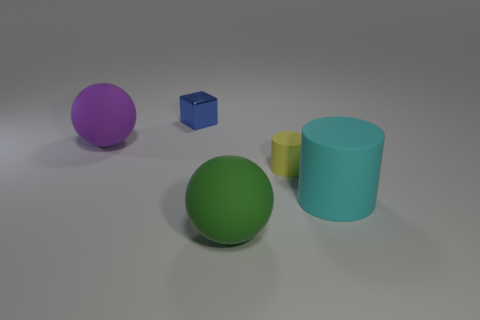Do the large green matte thing and the matte thing that is to the left of the tiny blue object have the same shape?
Ensure brevity in your answer.  Yes. What color is the tiny object that is to the left of the large ball that is to the right of the big sphere behind the cyan rubber thing?
Your response must be concise. Blue. There is a purple matte sphere; are there any tiny yellow things behind it?
Offer a very short reply. No. Is there a cylinder that has the same material as the large cyan object?
Your response must be concise. Yes. The big cylinder is what color?
Provide a short and direct response. Cyan. There is a rubber object in front of the large cyan cylinder; does it have the same shape as the tiny yellow thing?
Your answer should be compact. No. What is the shape of the matte object to the left of the metallic thing that is to the left of the rubber sphere on the right side of the tiny blue block?
Provide a short and direct response. Sphere. What is the material of the cylinder in front of the small yellow thing?
Ensure brevity in your answer.  Rubber. What is the color of the metallic block that is the same size as the yellow matte object?
Your answer should be very brief. Blue. What number of other things are the same shape as the purple matte thing?
Give a very brief answer. 1. 